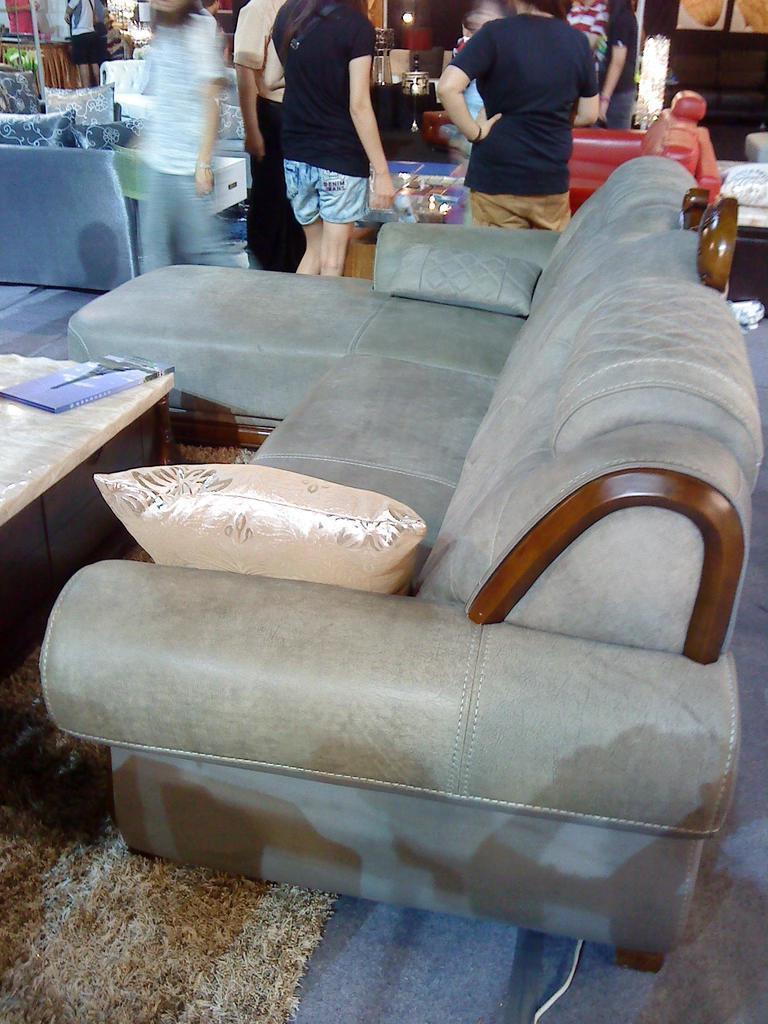Can you describe this image briefly? In this picture there is a couch with the pillow 